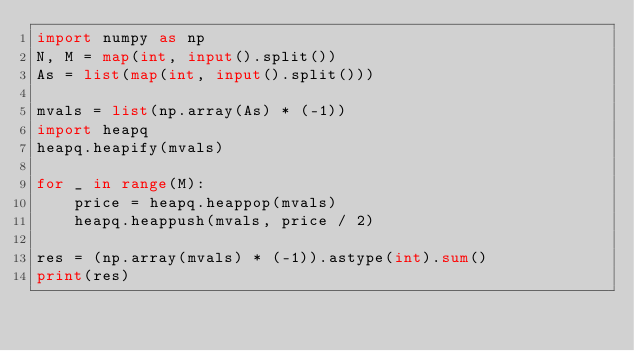Convert code to text. <code><loc_0><loc_0><loc_500><loc_500><_Python_>import numpy as np
N, M = map(int, input().split())
As = list(map(int, input().split()))

mvals = list(np.array(As) * (-1))
import heapq
heapq.heapify(mvals)

for _ in range(M):
    price = heapq.heappop(mvals)
    heapq.heappush(mvals, price / 2)

res = (np.array(mvals) * (-1)).astype(int).sum()
print(res)</code> 